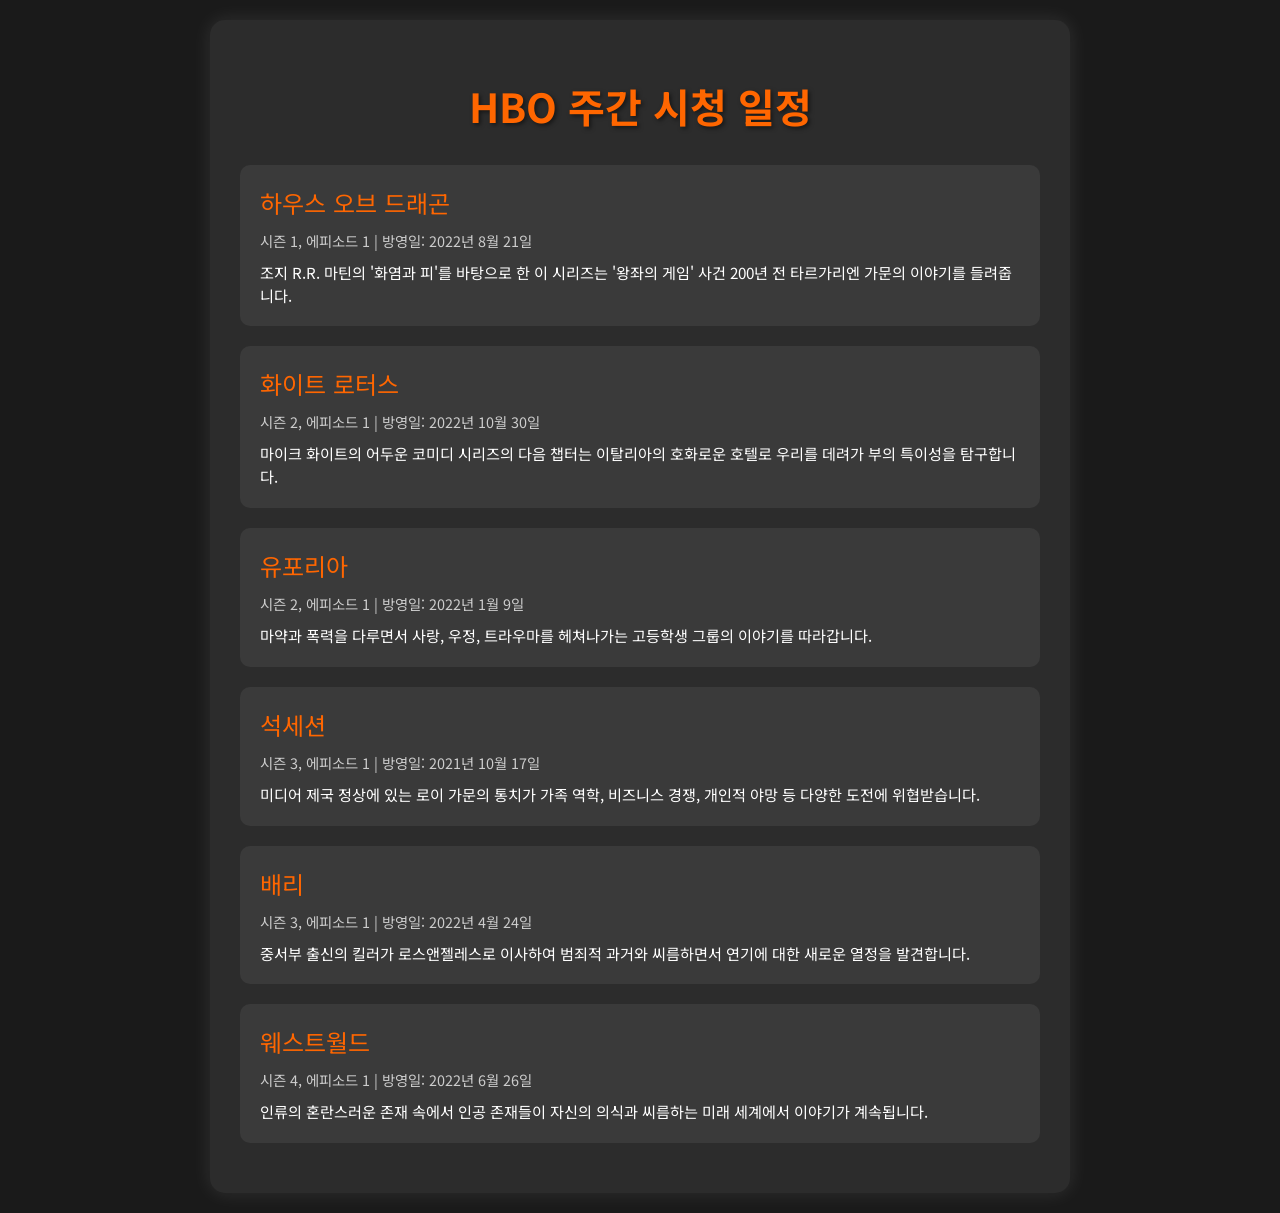하우스 오브 드래곤의 방영일은? This question is asking for the specific air date of the show "하우스 오브 드래곤" mentioned in the schedule.
Answer: 2022년 8월 21일 화이트 로터스의 시즌 몇이 방영되나요? This question inquires about the season number of "화이트 로터스" as indicated in the document.
Answer: 시즌 2 유포리아의 첫 번째 에피소드 방영일은? This question seeks the air date of the first episode of "유포리아" provided in the schedule.
Answer: 2022년 1월 9일 석세션에서 다루는 주제는 무엇인가요? This question requires an understanding of the theme of "석세션" as summarized in the synopsis.
Answer: 가족 역학, 비즈니스 경쟁, 개인적 야망 배리의 주인공 직업은 무엇인가요? This question looks for the profession of the main character in "배리" mentioned in the synopsis.
Answer: 킬러 웨스트월드의 시즌 몇 에피소드인지? This question asks for the season of "웨스트월드" as noted in the schedule.
Answer: 시즌 4 가장 최근에 방영된 에피소드는 어떤 것인가요? This question requires reasoning to find the most recent air date episode mentioned in the document.
Answer: 하우스 오브 드래곤 유포리아의 주제는 무엇인가요? This question looks for the central theme or issues addressed in "유포리아" as summarized in the document.
Answer: 마약과 폭력, 사랑, 우정, 트라우마 